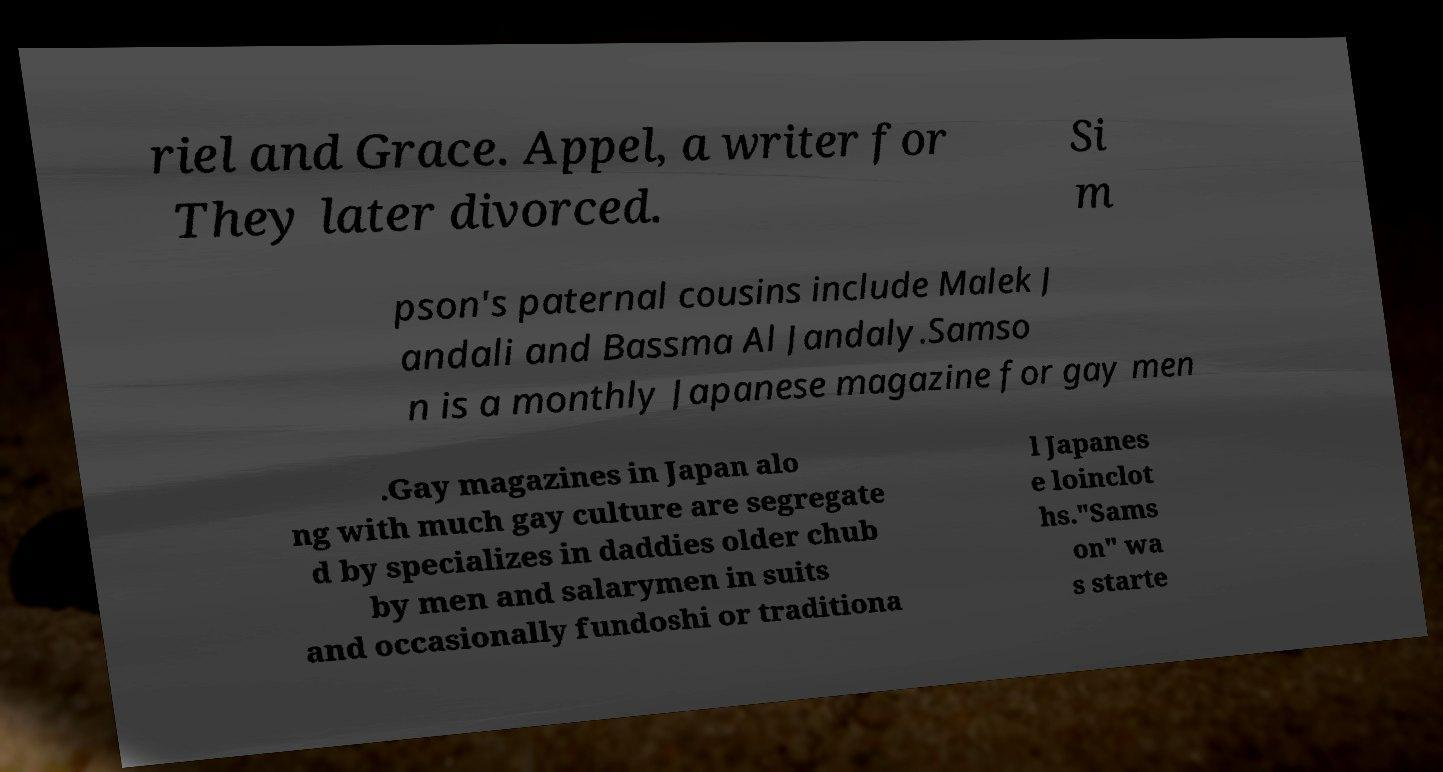Please identify and transcribe the text found in this image. riel and Grace. Appel, a writer for They later divorced. Si m pson's paternal cousins include Malek J andali and Bassma Al Jandaly.Samso n is a monthly Japanese magazine for gay men .Gay magazines in Japan alo ng with much gay culture are segregate d by specializes in daddies older chub by men and salarymen in suits and occasionally fundoshi or traditiona l Japanes e loinclot hs."Sams on" wa s starte 